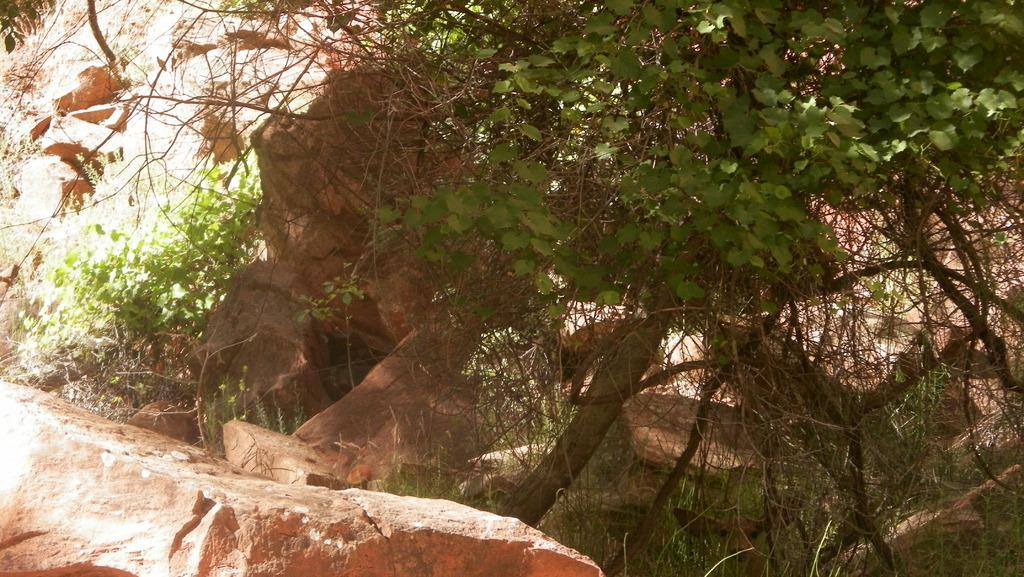What is the main geographical feature in the image? There is a mountain in the image. Are there any plants or vegetation on the mountain? Yes, there is a tree on the mountain. How many cows can be seen grazing on the mountain in the image? There are no cows present in the image; it only features a mountain and a tree. 